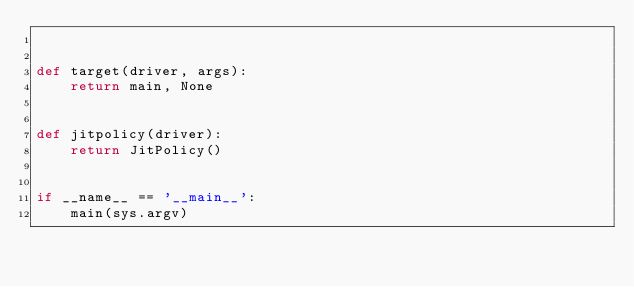Convert code to text. <code><loc_0><loc_0><loc_500><loc_500><_Python_>

def target(driver, args):
    return main, None


def jitpolicy(driver):
    return JitPolicy()


if __name__ == '__main__':
    main(sys.argv)
</code> 